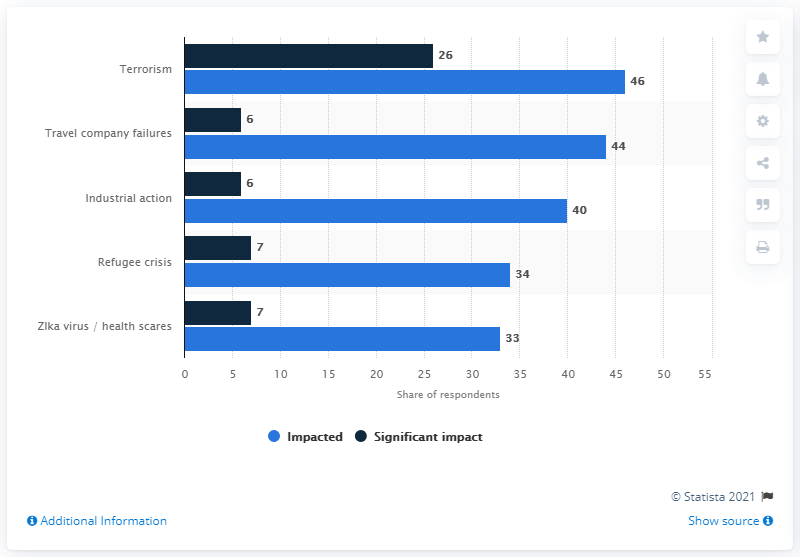Outline some significant characteristics in this image. Travel industry executives reported that terrorism had a significant impact on approximately 46% of their businesses, according to a recent survey. According to a survey of travel industry executives, 26% believed that terrorism had a significant impact on their businesses in 2017. 